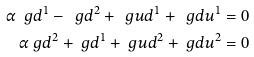Convert formula to latex. <formula><loc_0><loc_0><loc_500><loc_500>\alpha \ g d ^ { 1 } - \ g d ^ { 2 } + \ g u d ^ { 1 } + \ g d u ^ { 1 } & = 0 \\ \alpha \ g d ^ { 2 } + \ g d ^ { 1 } + \ g u d ^ { 2 } + \ g d u ^ { 2 } & = 0</formula> 